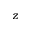Convert formula to latex. <formula><loc_0><loc_0><loc_500><loc_500>z</formula> 